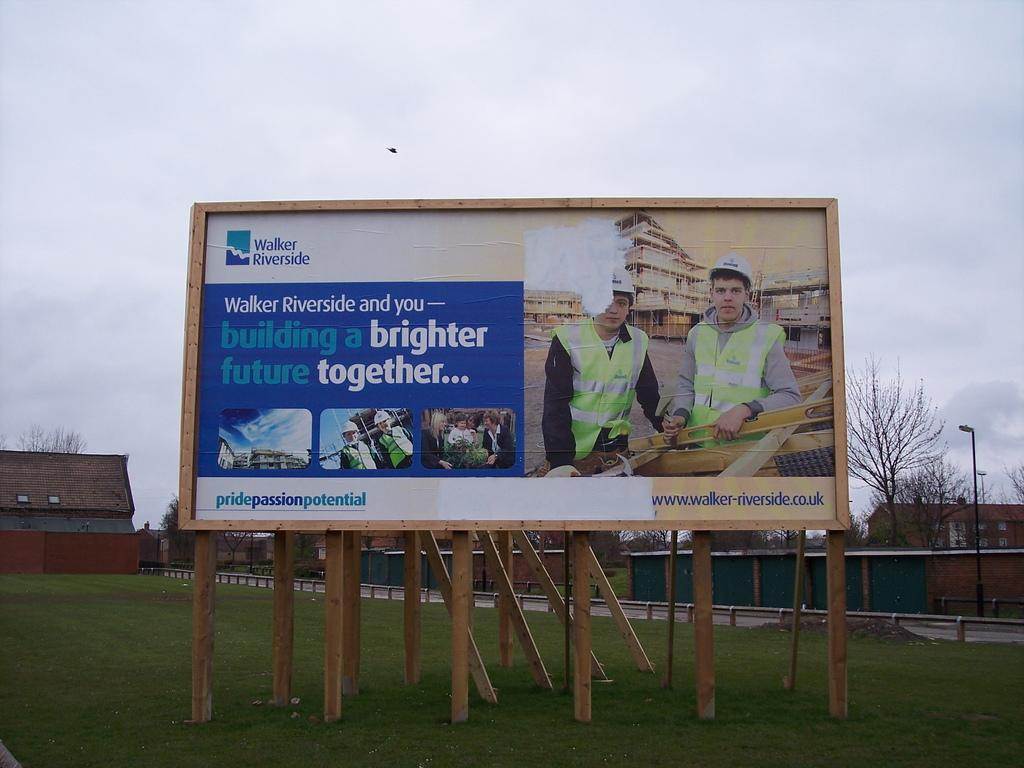<image>
Give a short and clear explanation of the subsequent image. A Walker Riverside sign contains the phrase pride-passion-potential near the bottom. 